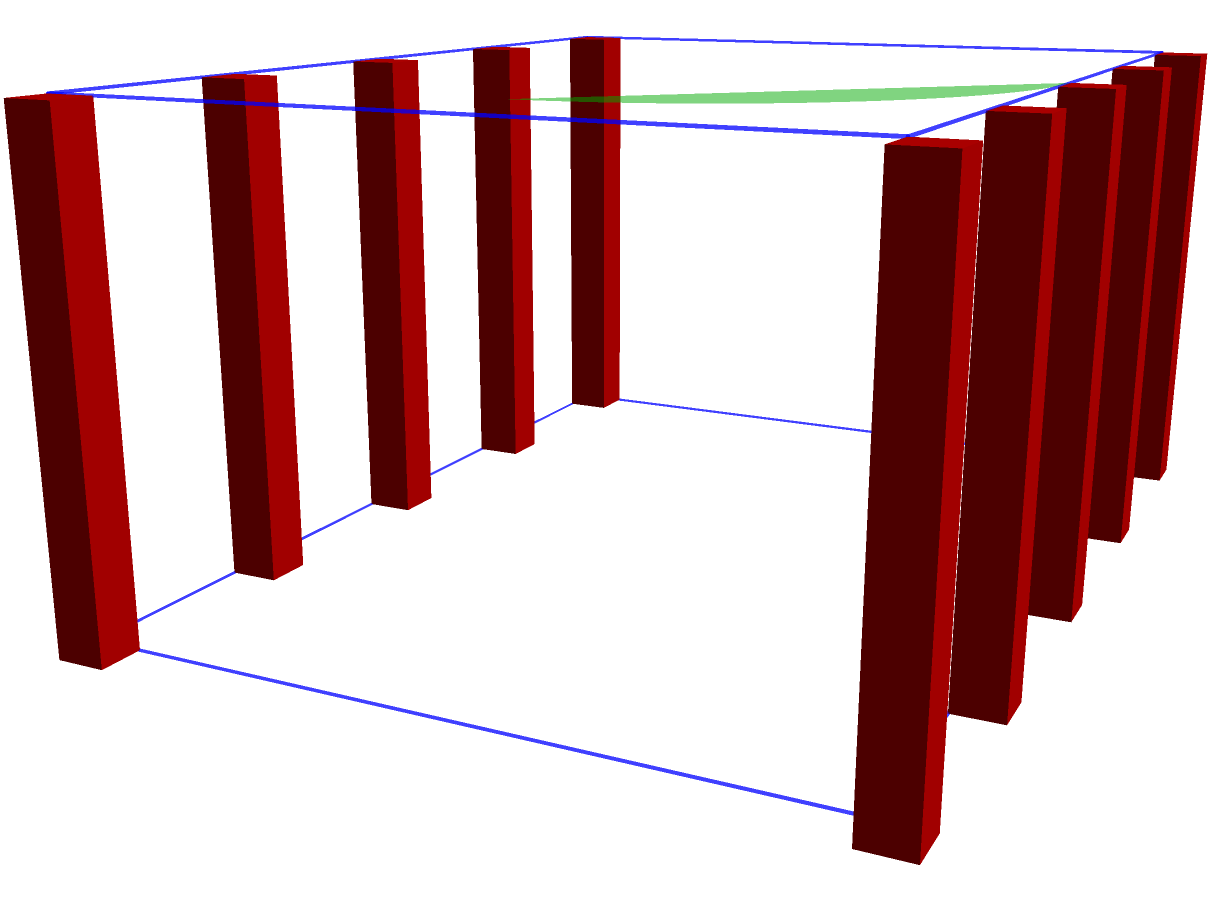Consider a simplified 3D model of the Bangladeshi Parliament building, consisting of a rectangular prism base, a dome, and 10 pillars. Calculate the Euler characteristic of this model. How does this value relate to the topological properties of the structure? To calculate the Euler characteristic of the 3D model, we'll follow these steps:

1. Identify the components:
   - Rectangular prism (main building)
   - Dome (half-sphere)
   - 10 Pillars (cylinders)

2. Calculate the Euler characteristic for each component:

   a) Rectangular prism:
      - Vertices (V) = 8
      - Edges (E) = 12
      - Faces (F) = 6
      Euler characteristic = V - E + F = 8 - 12 + 6 = 2

   b) Dome (half-sphere):
      - Topologically equivalent to a disk
      Euler characteristic = 1

   c) Pillars (cylinders):
      - Each pillar is topologically equivalent to a disk
      Euler characteristic of each pillar = 1
      Total for 10 pillars = 10 × 1 = 10

3. Sum up the Euler characteristics:
   Total Euler characteristic = 2 + 1 + 10 = 13

4. Interpret the result:
   The Euler characteristic of 13 indicates that the structure is not a simple polyhedron (which would have an Euler characteristic of 2). This higher value reflects the complex topology of the building, with multiple disconnected components (pillars) and the addition of the dome.

5. Relation to topological properties:
   - The non-zero Euler characteristic indicates that the structure is not a torus or any other surface with holes.
   - The positive value suggests that the structure has more "solid" components than holes or tunnels.
   - The high value (13) reflects the complexity of the structure, with multiple disconnected parts contributing to its overall topology.
Answer: 13 